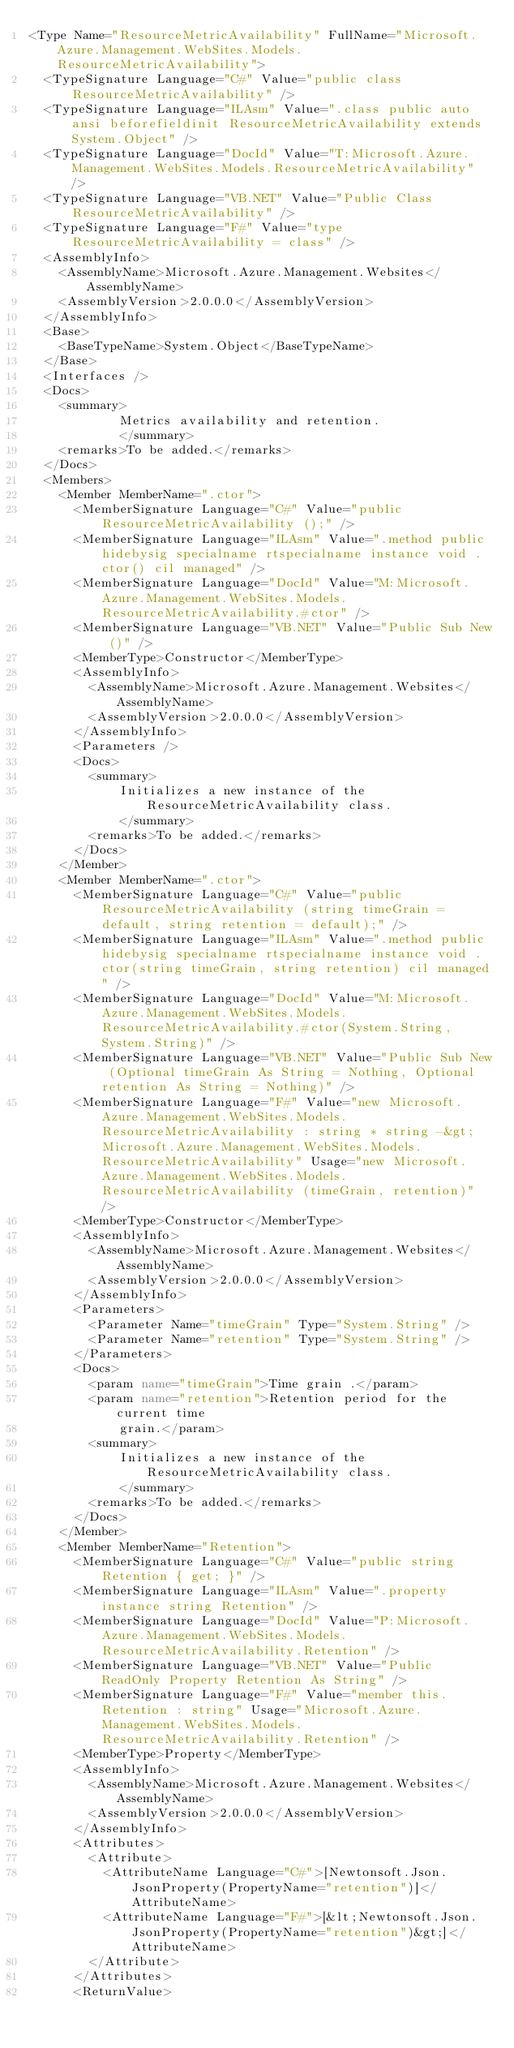<code> <loc_0><loc_0><loc_500><loc_500><_XML_><Type Name="ResourceMetricAvailability" FullName="Microsoft.Azure.Management.WebSites.Models.ResourceMetricAvailability">
  <TypeSignature Language="C#" Value="public class ResourceMetricAvailability" />
  <TypeSignature Language="ILAsm" Value=".class public auto ansi beforefieldinit ResourceMetricAvailability extends System.Object" />
  <TypeSignature Language="DocId" Value="T:Microsoft.Azure.Management.WebSites.Models.ResourceMetricAvailability" />
  <TypeSignature Language="VB.NET" Value="Public Class ResourceMetricAvailability" />
  <TypeSignature Language="F#" Value="type ResourceMetricAvailability = class" />
  <AssemblyInfo>
    <AssemblyName>Microsoft.Azure.Management.Websites</AssemblyName>
    <AssemblyVersion>2.0.0.0</AssemblyVersion>
  </AssemblyInfo>
  <Base>
    <BaseTypeName>System.Object</BaseTypeName>
  </Base>
  <Interfaces />
  <Docs>
    <summary>
            Metrics availability and retention.
            </summary>
    <remarks>To be added.</remarks>
  </Docs>
  <Members>
    <Member MemberName=".ctor">
      <MemberSignature Language="C#" Value="public ResourceMetricAvailability ();" />
      <MemberSignature Language="ILAsm" Value=".method public hidebysig specialname rtspecialname instance void .ctor() cil managed" />
      <MemberSignature Language="DocId" Value="M:Microsoft.Azure.Management.WebSites.Models.ResourceMetricAvailability.#ctor" />
      <MemberSignature Language="VB.NET" Value="Public Sub New ()" />
      <MemberType>Constructor</MemberType>
      <AssemblyInfo>
        <AssemblyName>Microsoft.Azure.Management.Websites</AssemblyName>
        <AssemblyVersion>2.0.0.0</AssemblyVersion>
      </AssemblyInfo>
      <Parameters />
      <Docs>
        <summary>
            Initializes a new instance of the ResourceMetricAvailability class.
            </summary>
        <remarks>To be added.</remarks>
      </Docs>
    </Member>
    <Member MemberName=".ctor">
      <MemberSignature Language="C#" Value="public ResourceMetricAvailability (string timeGrain = default, string retention = default);" />
      <MemberSignature Language="ILAsm" Value=".method public hidebysig specialname rtspecialname instance void .ctor(string timeGrain, string retention) cil managed" />
      <MemberSignature Language="DocId" Value="M:Microsoft.Azure.Management.WebSites.Models.ResourceMetricAvailability.#ctor(System.String,System.String)" />
      <MemberSignature Language="VB.NET" Value="Public Sub New (Optional timeGrain As String = Nothing, Optional retention As String = Nothing)" />
      <MemberSignature Language="F#" Value="new Microsoft.Azure.Management.WebSites.Models.ResourceMetricAvailability : string * string -&gt; Microsoft.Azure.Management.WebSites.Models.ResourceMetricAvailability" Usage="new Microsoft.Azure.Management.WebSites.Models.ResourceMetricAvailability (timeGrain, retention)" />
      <MemberType>Constructor</MemberType>
      <AssemblyInfo>
        <AssemblyName>Microsoft.Azure.Management.Websites</AssemblyName>
        <AssemblyVersion>2.0.0.0</AssemblyVersion>
      </AssemblyInfo>
      <Parameters>
        <Parameter Name="timeGrain" Type="System.String" />
        <Parameter Name="retention" Type="System.String" />
      </Parameters>
      <Docs>
        <param name="timeGrain">Time grain .</param>
        <param name="retention">Retention period for the current time
            grain.</param>
        <summary>
            Initializes a new instance of the ResourceMetricAvailability class.
            </summary>
        <remarks>To be added.</remarks>
      </Docs>
    </Member>
    <Member MemberName="Retention">
      <MemberSignature Language="C#" Value="public string Retention { get; }" />
      <MemberSignature Language="ILAsm" Value=".property instance string Retention" />
      <MemberSignature Language="DocId" Value="P:Microsoft.Azure.Management.WebSites.Models.ResourceMetricAvailability.Retention" />
      <MemberSignature Language="VB.NET" Value="Public ReadOnly Property Retention As String" />
      <MemberSignature Language="F#" Value="member this.Retention : string" Usage="Microsoft.Azure.Management.WebSites.Models.ResourceMetricAvailability.Retention" />
      <MemberType>Property</MemberType>
      <AssemblyInfo>
        <AssemblyName>Microsoft.Azure.Management.Websites</AssemblyName>
        <AssemblyVersion>2.0.0.0</AssemblyVersion>
      </AssemblyInfo>
      <Attributes>
        <Attribute>
          <AttributeName Language="C#">[Newtonsoft.Json.JsonProperty(PropertyName="retention")]</AttributeName>
          <AttributeName Language="F#">[&lt;Newtonsoft.Json.JsonProperty(PropertyName="retention")&gt;]</AttributeName>
        </Attribute>
      </Attributes>
      <ReturnValue></code> 